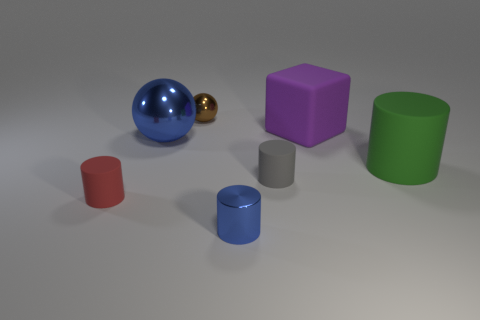What mood does the combination of objects and lighting create? The combination of simple geometric shapes, a muted color palette, and the soft, diffuse lighting creates a tranquil and somewhat abstract mood. It's reminiscent of a modern art installation, evoking a sense of serenity and contemplation. 